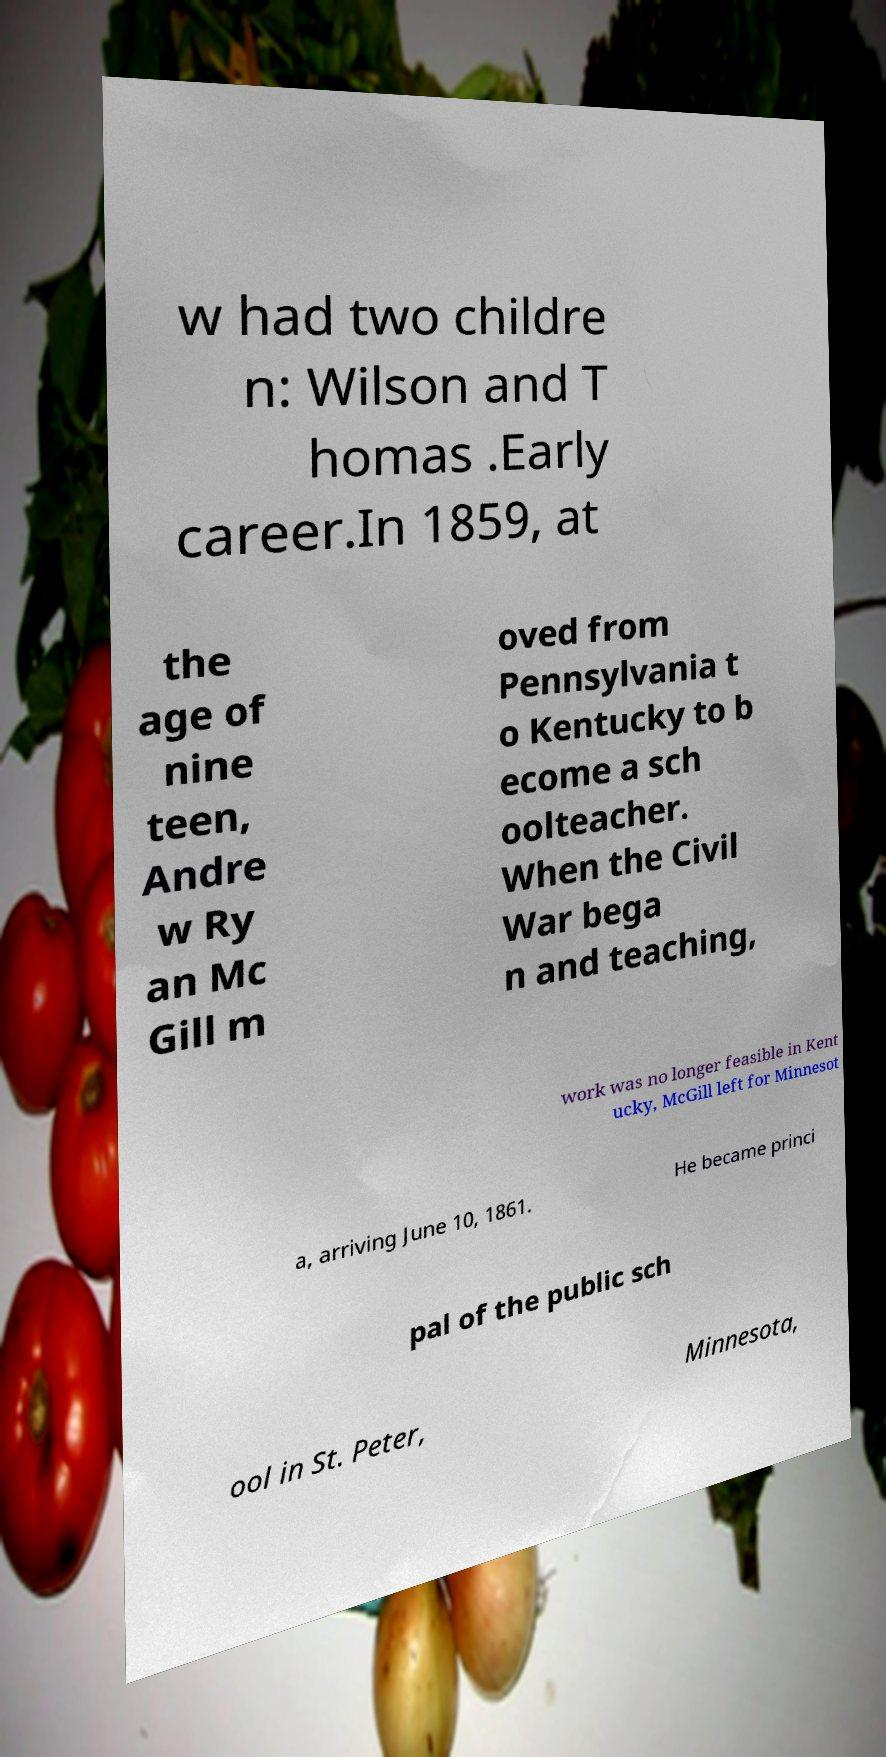For documentation purposes, I need the text within this image transcribed. Could you provide that? w had two childre n: Wilson and T homas .Early career.In 1859, at the age of nine teen, Andre w Ry an Mc Gill m oved from Pennsylvania t o Kentucky to b ecome a sch oolteacher. When the Civil War bega n and teaching, work was no longer feasible in Kent ucky, McGill left for Minnesot a, arriving June 10, 1861. He became princi pal of the public sch ool in St. Peter, Minnesota, 